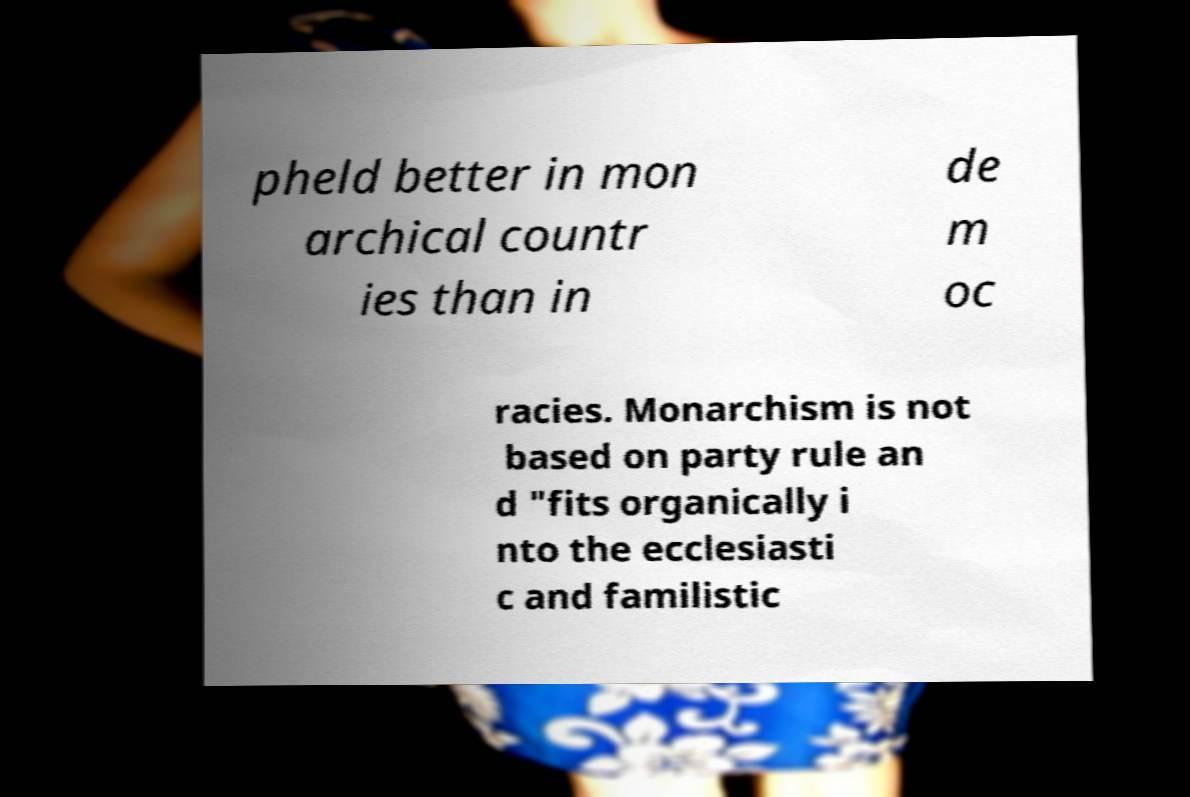Could you extract and type out the text from this image? pheld better in mon archical countr ies than in de m oc racies. Monarchism is not based on party rule an d "fits organically i nto the ecclesiasti c and familistic 